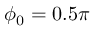<formula> <loc_0><loc_0><loc_500><loc_500>\phi _ { 0 } = 0 . 5 \pi</formula> 